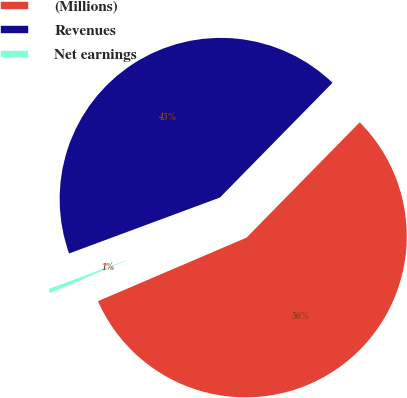Convert chart to OTSL. <chart><loc_0><loc_0><loc_500><loc_500><pie_chart><fcel>(Millions)<fcel>Revenues<fcel>Net earnings<nl><fcel>56.22%<fcel>43.0%<fcel>0.78%<nl></chart> 